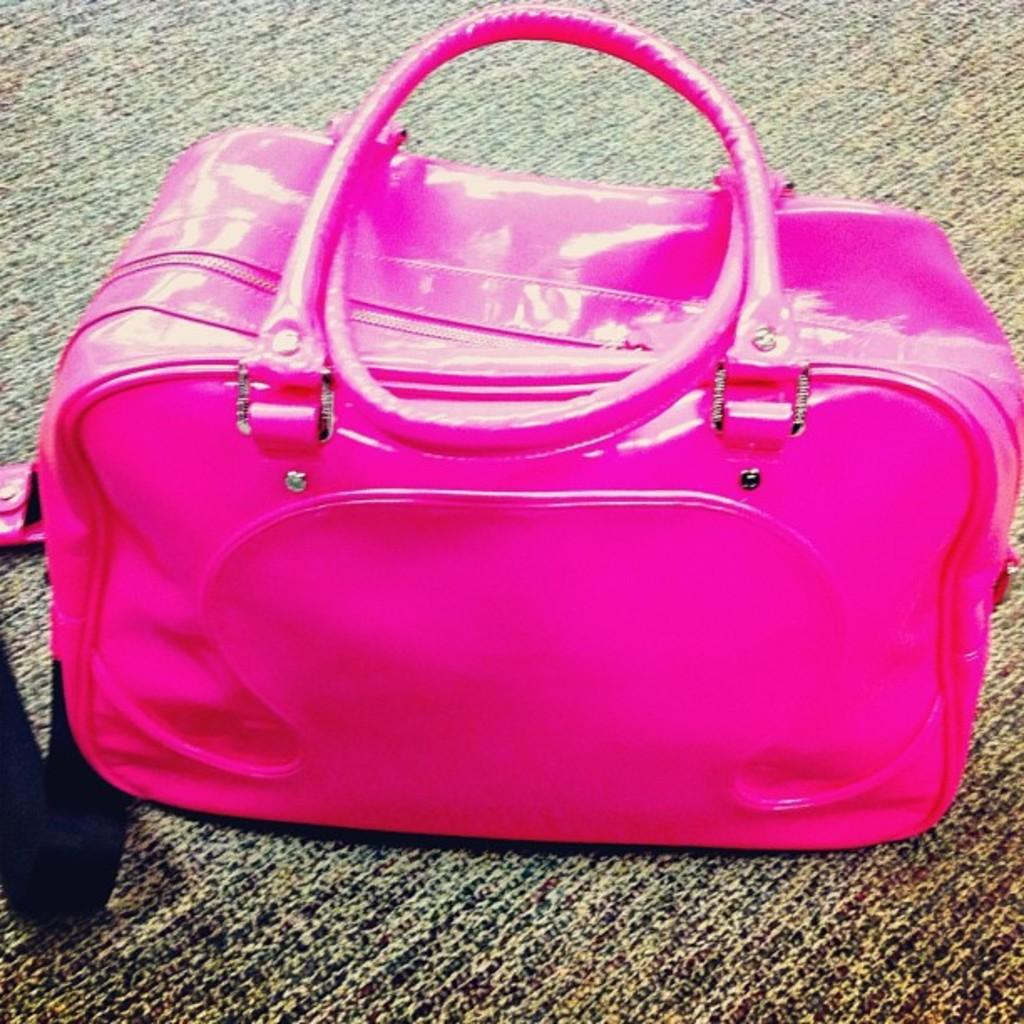Where was the image taken? The image was taken inside a room. Who is present in the image? There is a man in the image. What is the man wearing? The man is wearing pink color. What is the man's position in the image? The man is on the floor. What can be seen at the bottom of the image? There is a floor mat at the bottom of the image. What type of rabbit can be seen hopping on the floor mat in the image? There is no rabbit present in the image; it only features a man wearing pink and a floor mat. Is there a lamp visible in the image? No, there is no lamp present in the image. 